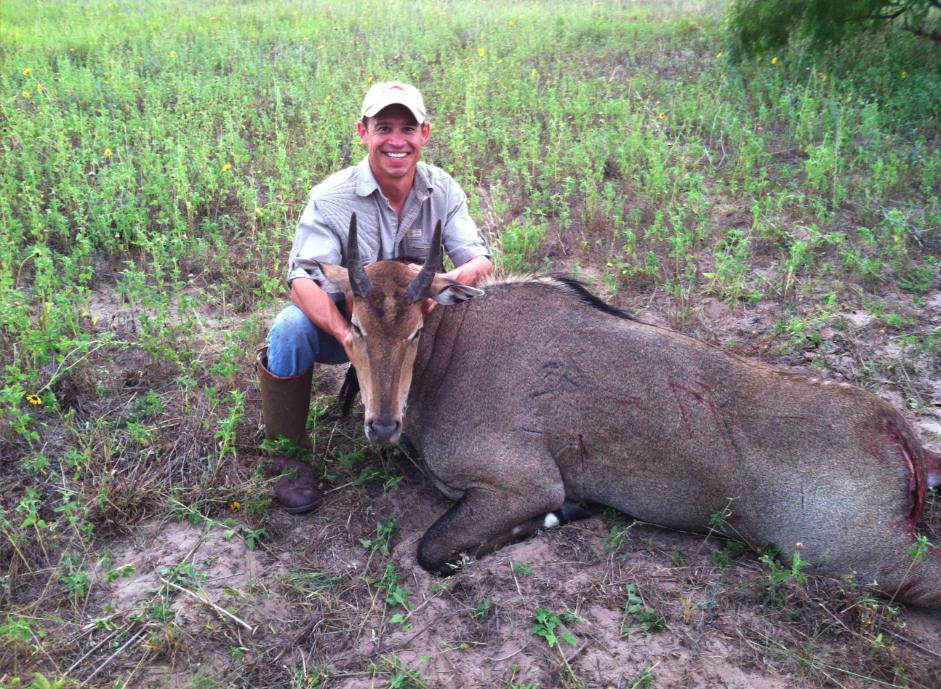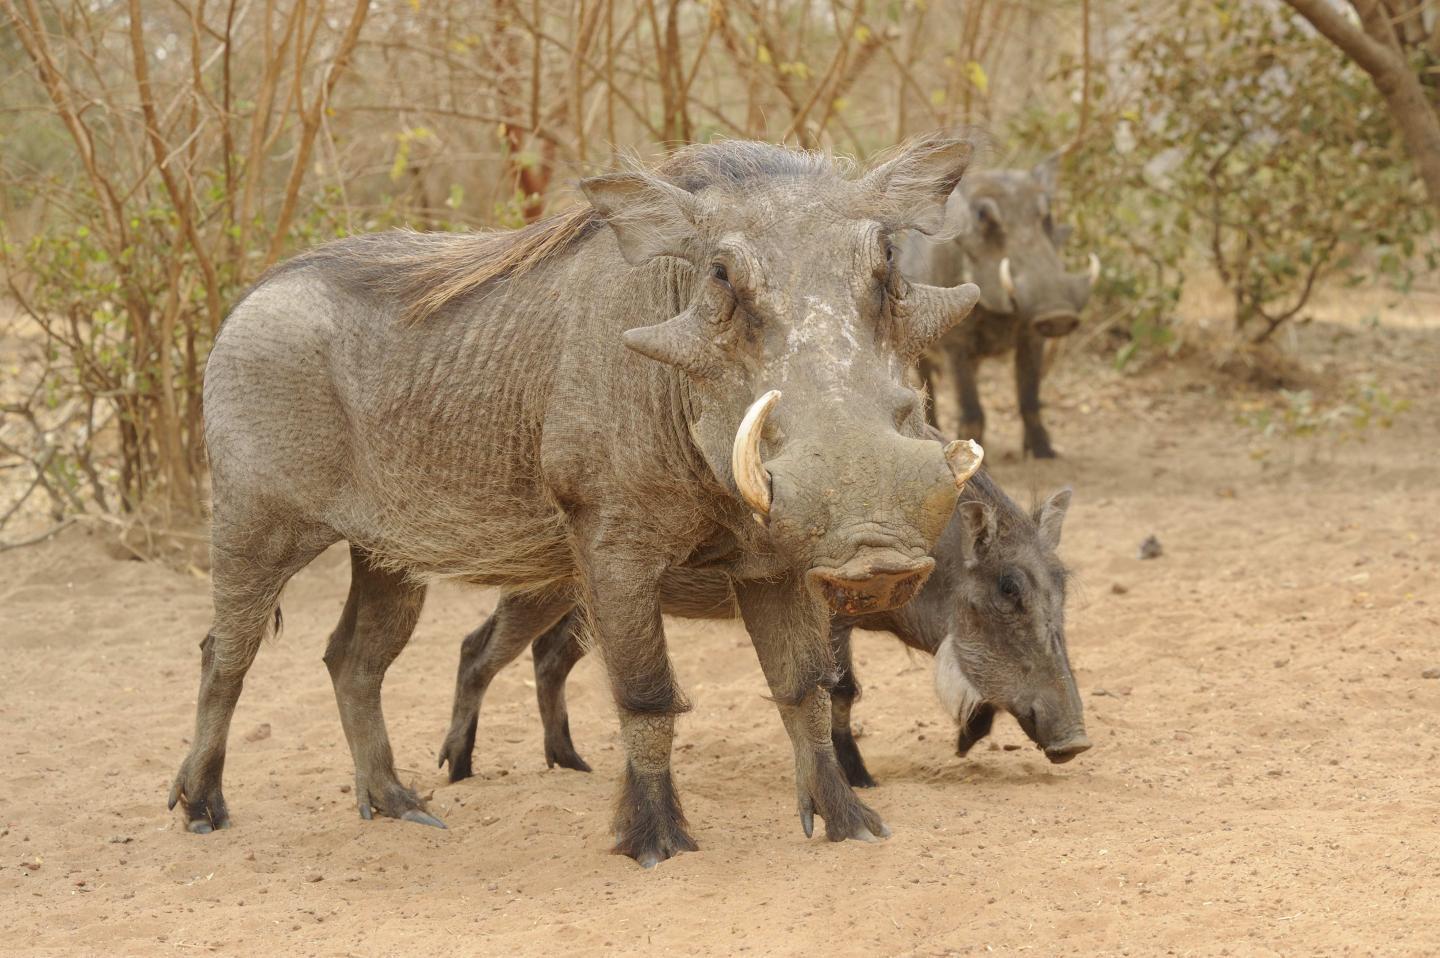The first image is the image on the left, the second image is the image on the right. Considering the images on both sides, is "The image on the left shows a hunter wearing a hat and posing with his prey." valid? Answer yes or no. Yes. The first image is the image on the left, the second image is the image on the right. Analyze the images presented: Is the assertion "there is exactly one human in the image on the left" valid? Answer yes or no. Yes. 